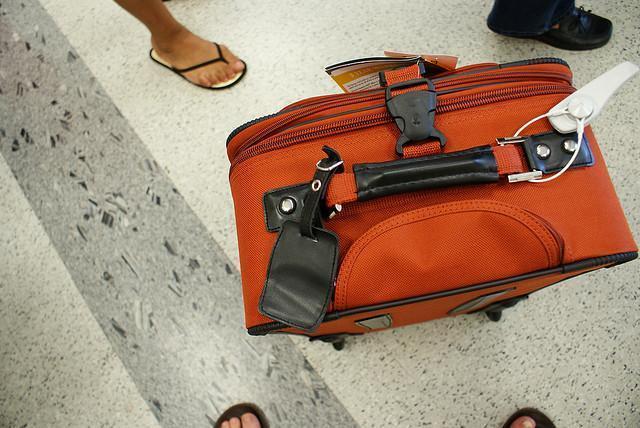How many big toes are visible?
Give a very brief answer. 3. How many people can you see?
Give a very brief answer. 2. How many suitcases can be seen?
Give a very brief answer. 1. 